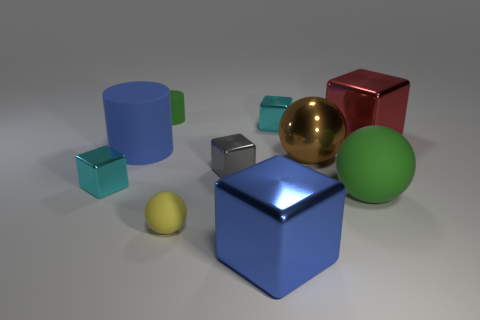Subtract all big shiny blocks. How many blocks are left? 3 Subtract 3 cubes. How many cubes are left? 2 Subtract all blue cylinders. How many cyan blocks are left? 2 Subtract all spheres. How many objects are left? 7 Subtract all gray blocks. How many blocks are left? 4 Subtract 1 yellow balls. How many objects are left? 9 Subtract all gray balls. Subtract all yellow blocks. How many balls are left? 3 Subtract all green balls. Subtract all large green spheres. How many objects are left? 8 Add 5 gray cubes. How many gray cubes are left? 6 Add 8 large gray shiny blocks. How many large gray shiny blocks exist? 8 